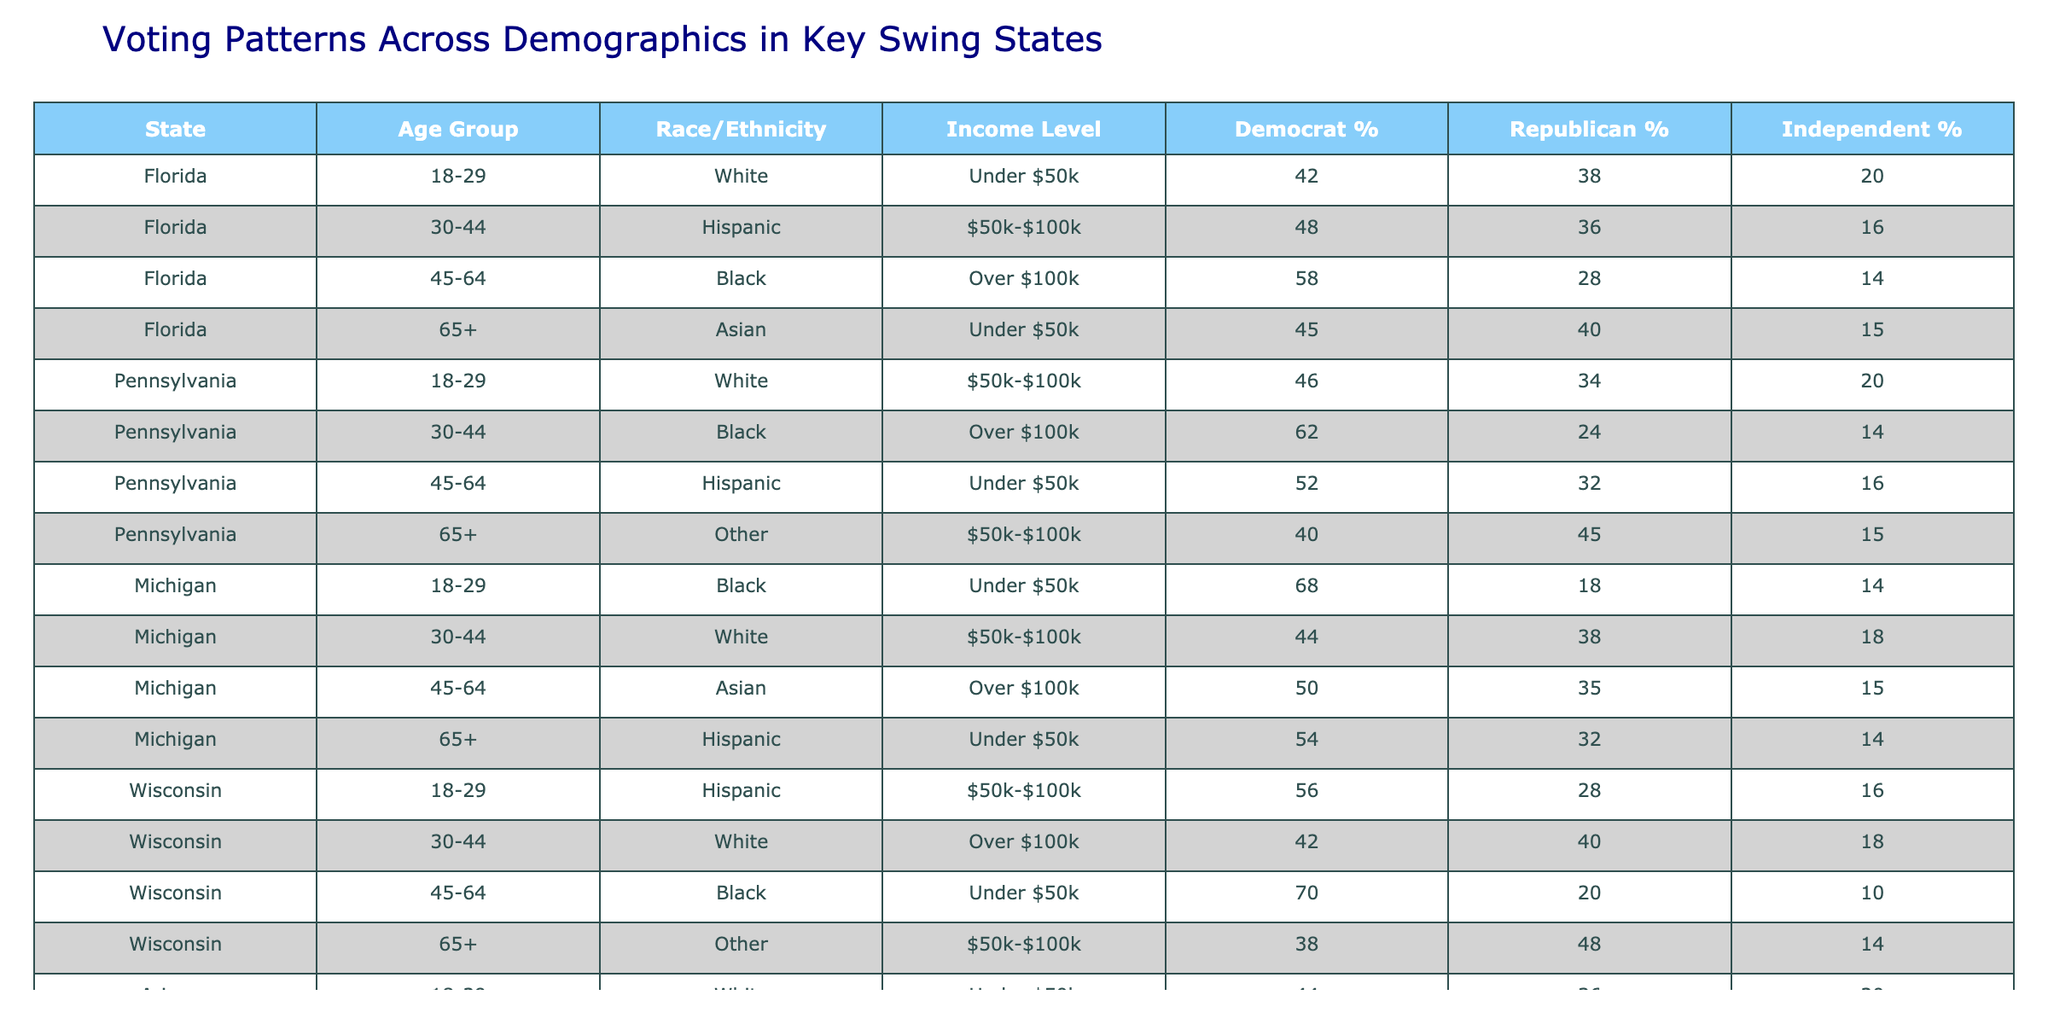What is the percentage of Hispanic voters aged 30-44 in Florida? In the table, looking at the row for Florida under the age group 30-44 and race/ethnicity Hispanic, the percentage for Democrats is 48%.
Answer: 48% Which state has the highest percentage of Black voters aged 18-29? From the table, Michigan has the highest percentage of Black voters aged 18-29 at 68%.
Answer: Michigan What is the income level of the majority of Black voters aged 45-64 in Pennsylvania? The income level for Black voters aged 45-64 in Pennsylvania is listed as 'Under $50k'.
Answer: Under $50k How does the percentage of Republican voters aged 65 and older in Arizona compare to that in Florida? In Arizona, the percentage of Republican voters aged 65 and older is 42%, while in Florida it's 40%. Comparing these, Arizona has a higher percentage by 2%.
Answer: Arizona is higher by 2% What is the average percentage of Independent voters across all age groups in Wisconsin? The Independent percentages in Wisconsin are 16%, 18%, 10%, and 14%. Summing these gives 58% and dividing by 4 provides an average of 14.5%.
Answer: 14.5% Is it true that the percentage of Democrat voters is consistently higher among Black voters compared to White voters across all states presented? Analyzing the rows for each state shows that in Michigan and Pennsylvania, the Democrat percentage for Black voters is higher than for White voters, but in Florida, it's not. Thus, the statement is false.
Answer: False In which state do Asian voters aged 65 and older have the highest percentage of Democratic voters? By examining the table, we see that in Florida, the percentage of Democratic voters among Asian voters aged 65+ is 45%, which is the highest compared to Arizona’s 46% for the same demographic.
Answer: Florida Which race/ethnicity has the lowest support for Republicans among the 45-64 age group across the states listed? Analyzing the table, we see that Black voters aged 45-64 in Wisconsin have the lowest percentage of support for Republicans at 20%.
Answer: Black voters in Wisconsin What is the difference in percentages between Democrat and Republican support among 30-44 age group Hispanic voters in Arizona? For Hispanic voters in Arizona aged 30-44, Democrat support is 52% and Republican support is 32%. The difference is 20%.
Answer: 20% Which demographic group has the lowest total percentage of Independent voters across all age groups in Pennsylvania? The total of the Independent percentages for Pennsylvania is for White (20%), Black (14%), Hispanic (16%), and other (15%). The lowest is among Black voters with 14%.
Answer: Black voters 